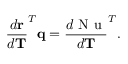<formula> <loc_0><loc_0><loc_500><loc_500>\frac { d r } { d T } ^ { T } q = \frac { d N u } { d T } ^ { T } .</formula> 